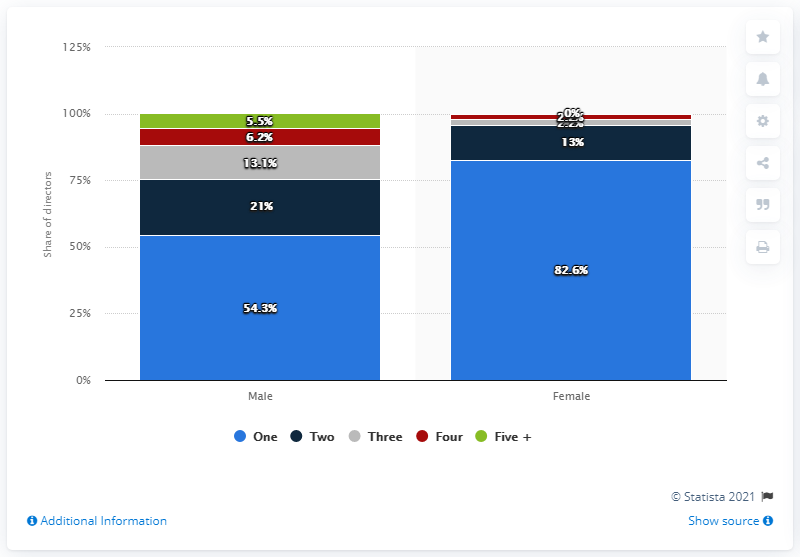Point out several critical features in this image. Out of all male directors who made at least five films between 2007 and 2018, 5.5% made five or more films during this period. 